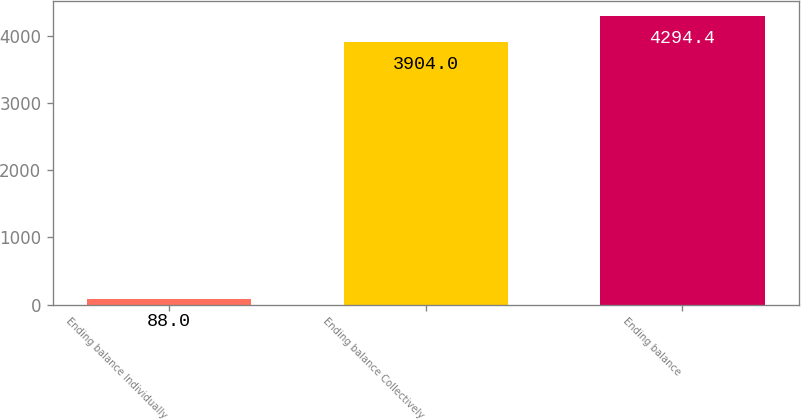<chart> <loc_0><loc_0><loc_500><loc_500><bar_chart><fcel>Ending balance Individually<fcel>Ending balance Collectively<fcel>Ending balance<nl><fcel>88<fcel>3904<fcel>4294.4<nl></chart> 